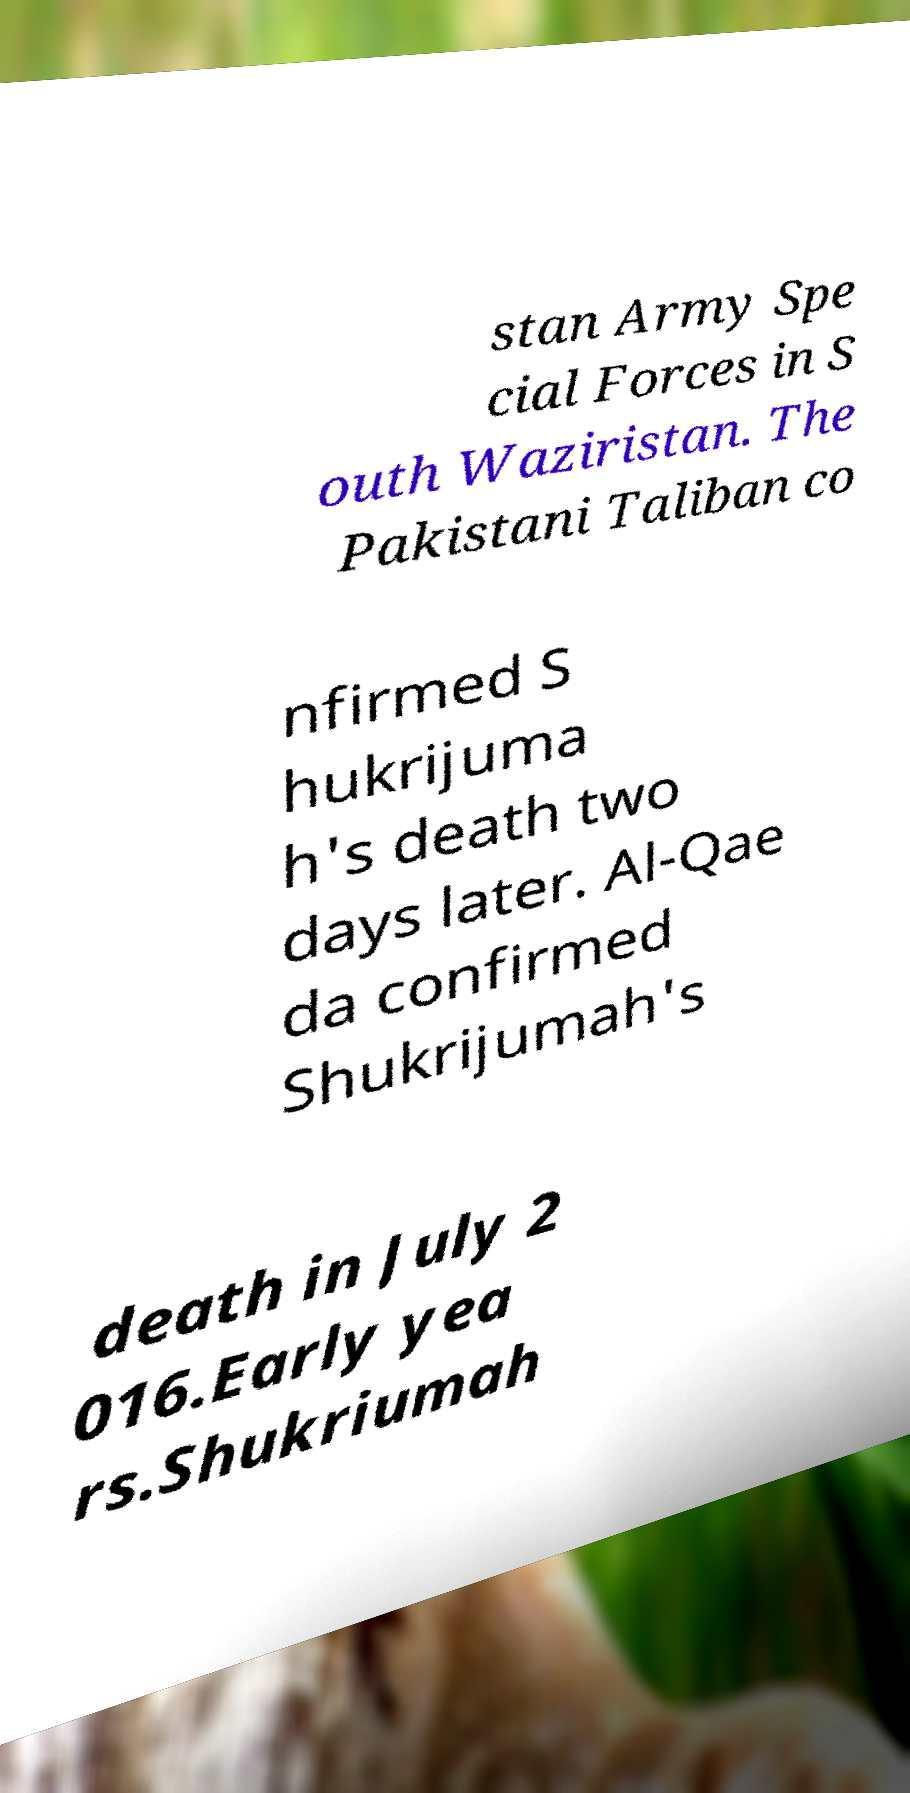Please read and relay the text visible in this image. What does it say? stan Army Spe cial Forces in S outh Waziristan. The Pakistani Taliban co nfirmed S hukrijuma h's death two days later. Al-Qae da confirmed Shukrijumah's death in July 2 016.Early yea rs.Shukriumah 